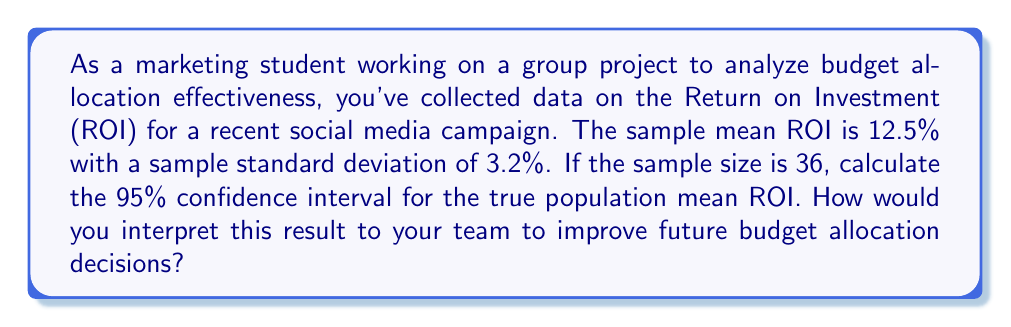Can you answer this question? Let's approach this step-by-step:

1) The formula for a confidence interval is:

   $$\bar{x} \pm t_{\alpha/2} \cdot \frac{s}{\sqrt{n}}$$

   Where:
   $\bar{x}$ = sample mean
   $t_{\alpha/2}$ = t-value for desired confidence level
   $s$ = sample standard deviation
   $n$ = sample size

2) We know:
   $\bar{x} = 12.5\%$
   $s = 3.2\%$
   $n = 36$
   Confidence level = 95% (α = 0.05)

3) For a 95% confidence interval with 35 degrees of freedom (n-1), the t-value is approximately 2.030 (from t-distribution table).

4) Plugging into the formula:

   $$12.5\% \pm 2.030 \cdot \frac{3.2\%}{\sqrt{36}}$$

5) Simplify:
   $$12.5\% \pm 2.030 \cdot \frac{3.2\%}{6} = 12.5\% \pm 2.030 \cdot 0.533\% = 12.5\% \pm 1.082\%$$

6) Therefore, the 95% confidence interval is:

   $$(12.5\% - 1.082\%, 12.5\% + 1.082\%) = (11.418\%, 13.582\%)$$

Interpretation: We can be 95% confident that the true population mean ROI for this type of social media campaign falls between 11.418% and 13.582%. This information can help the team make more informed decisions about budget allocation for future campaigns, considering the potential range of returns.
Answer: 95% CI: (11.418%, 13.582%) 